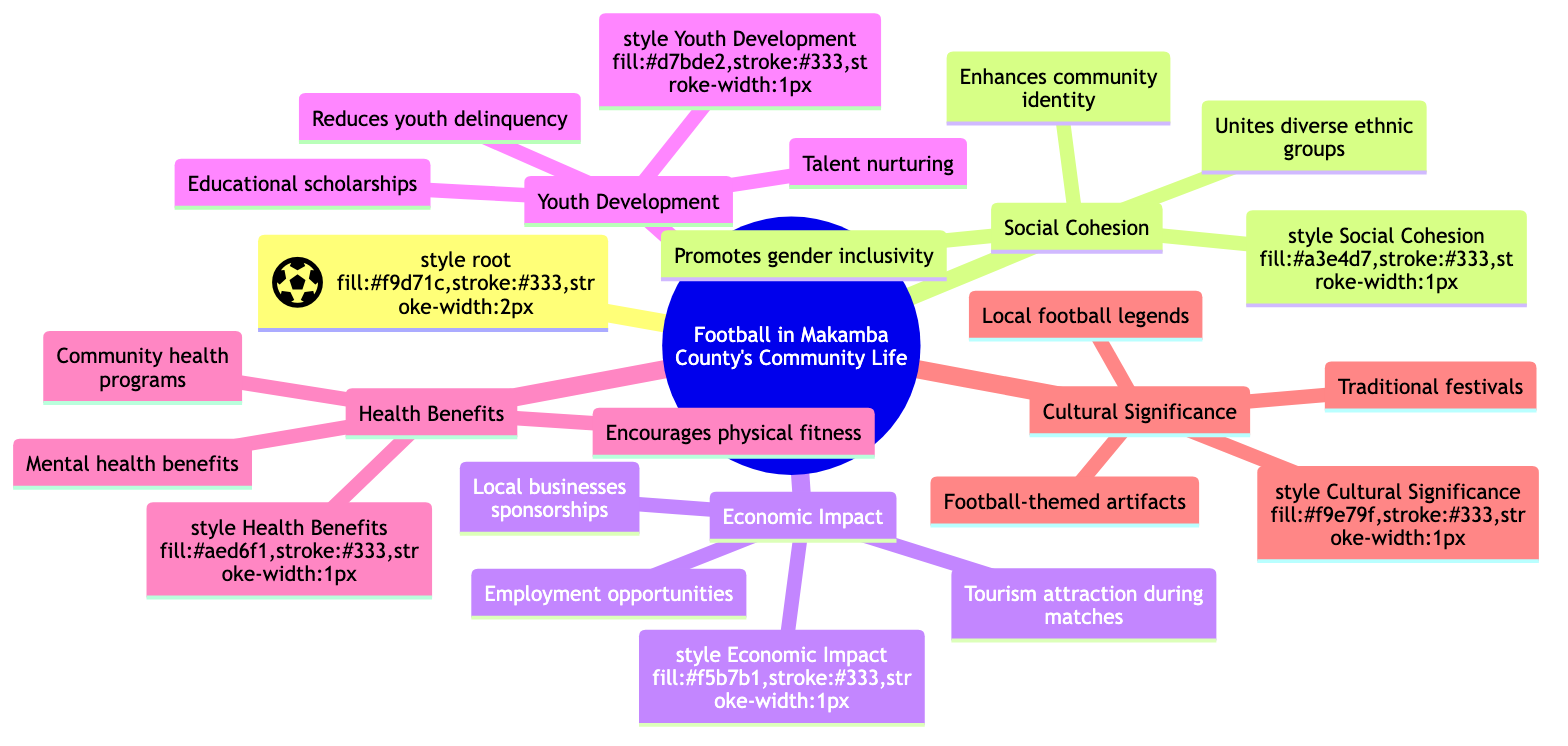What are the three elements of social cohesion? The diagram lists three specific elements under the "Social Cohesion" node: "Unites diverse ethnic groups", "Promotes gender inclusivity", and "Enhances community identity".
Answer: Unites diverse ethnic groups, Promotes gender inclusivity, Enhances community identity How many elements are listed under economic impact? There are three specific elements listed under the "Economic Impact" node: "Local businesses sponsorships", "Tourism attraction during matches", and "Employment opportunities in sports facilities".
Answer: 3 Which aspect promotes educational scholarships? The "Youth Development" node contains the element "Educational scholarships for athletes", indicating that this aspect directly promotes scholarships for education.
Answer: Youth Development What health benefit encourages physical fitness? The diagram specifies under the "Health Benefits" node the element "Encourages physical fitness", which is a direct mention of a health benefit correlated with football.
Answer: Encourages physical fitness How does football contribute to cultural significance? The "Cultural Significance" node lists three elements, including "Celebration of traditional festivals through football events", indicating that football contributes culturally through festival celebrations.
Answer: Celebration of traditional festivals through football events What is the relationship between football and youth delinquency? The "Youth Development" node mentions "Reduces youth delinquency", showing a direct relationship where involvement in football is suggested to help diminish delinquent behavior among youth.
Answer: Reduces youth delinquency What community benefit is associated with mental health? Under the "Health Benefits" node, "Mental health benefits" is identified as a direct benefit of participating in football activities within the community.
Answer: Mental health benefits How does football impact local businesses? The "Economic Impact" node includes "Local businesses sponsorships", indicating that football activities directly impact local businesses through sponsorships.
Answer: Local businesses sponsorships 